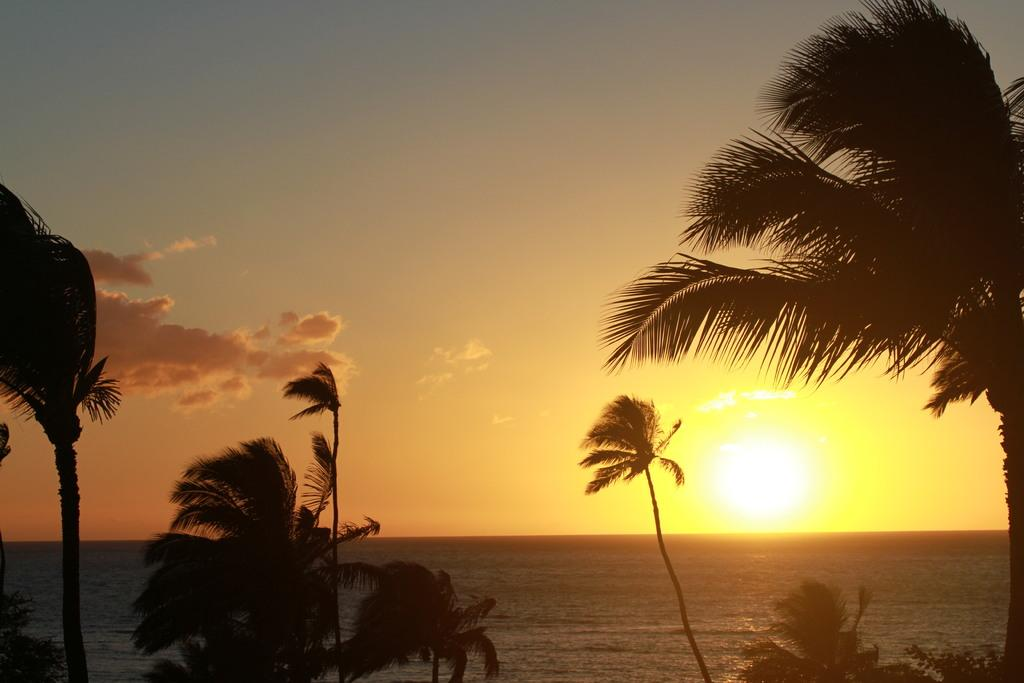What is visible in the sky in the image? Sky is visible in the image. What type of vegetation can be seen in the image? There are trees in the image. What natural element is visible in the image besides trees? There is water visible in the image. What celestial body can be seen in the sky in the image? The sun is observable in the image. What type of noise can be heard coming from the sail in the image? There is no sail present in the image, so it's not possible to determine what noise might be heard. 